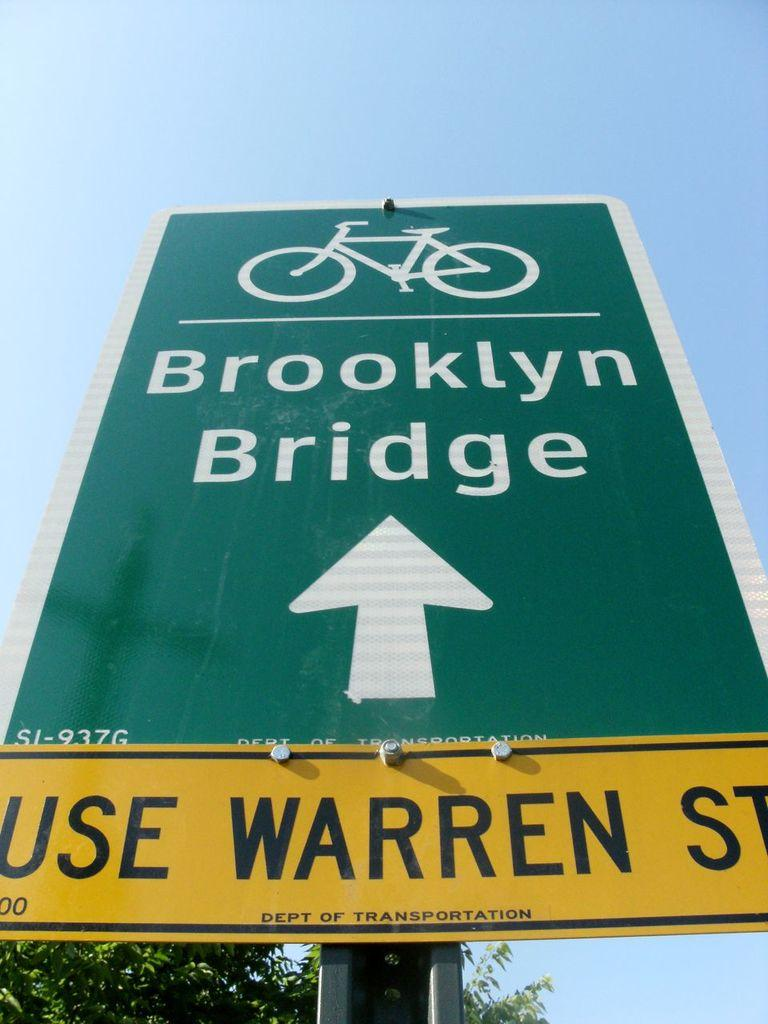<image>
Give a short and clear explanation of the subsequent image. A sign points the way for bicycles to go to the Brooklyn Bridge. 